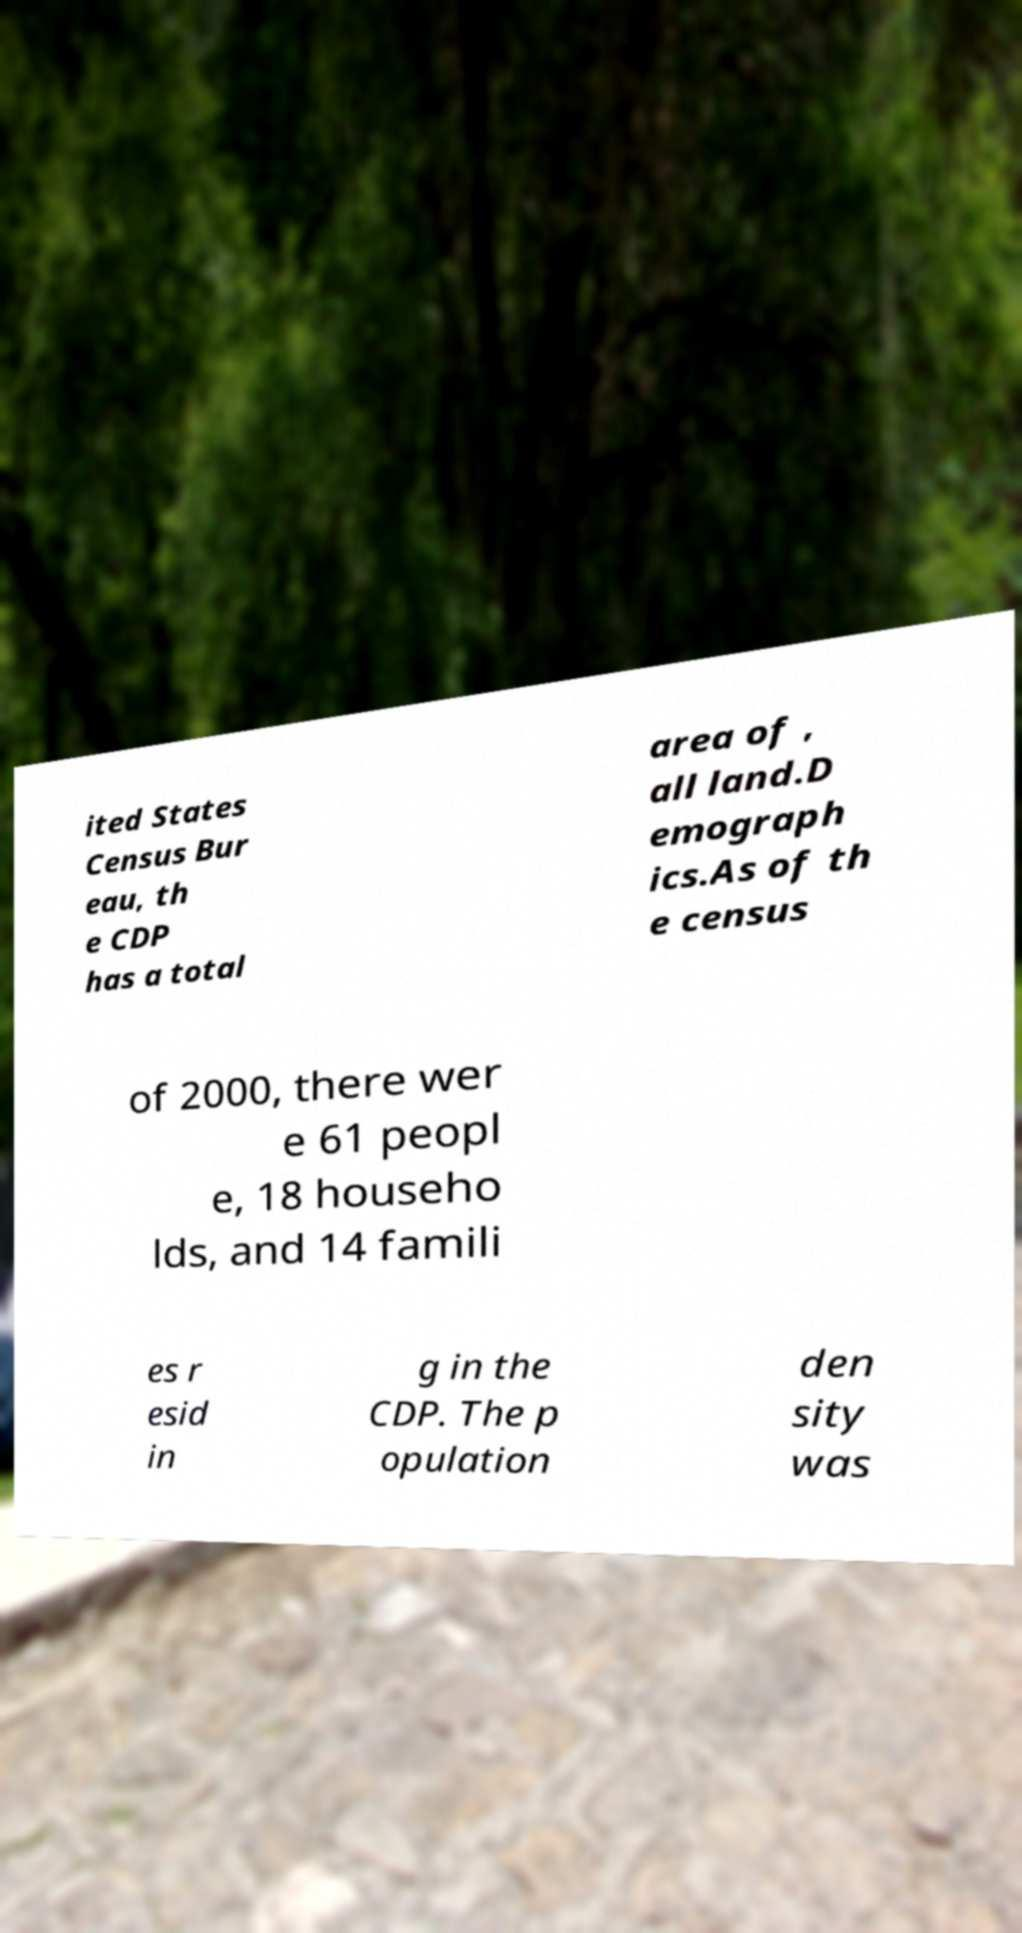Please identify and transcribe the text found in this image. ited States Census Bur eau, th e CDP has a total area of , all land.D emograph ics.As of th e census of 2000, there wer e 61 peopl e, 18 househo lds, and 14 famili es r esid in g in the CDP. The p opulation den sity was 